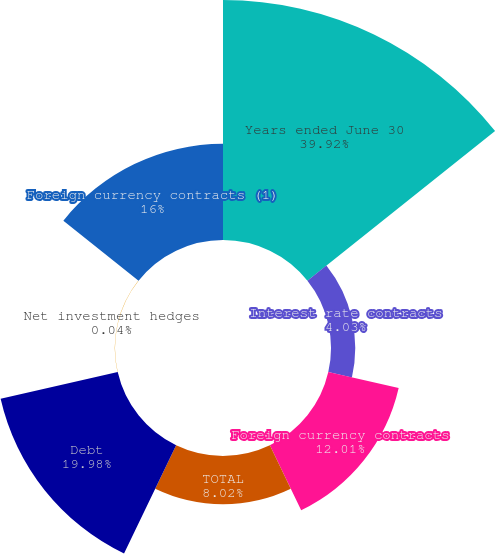Convert chart. <chart><loc_0><loc_0><loc_500><loc_500><pie_chart><fcel>Years ended June 30<fcel>Interest rate contracts<fcel>Foreign currency contracts<fcel>TOTAL<fcel>Debt<fcel>Net investment hedges<fcel>Foreign currency contracts (1)<nl><fcel>39.93%<fcel>4.03%<fcel>12.01%<fcel>8.02%<fcel>19.98%<fcel>0.04%<fcel>16.0%<nl></chart> 